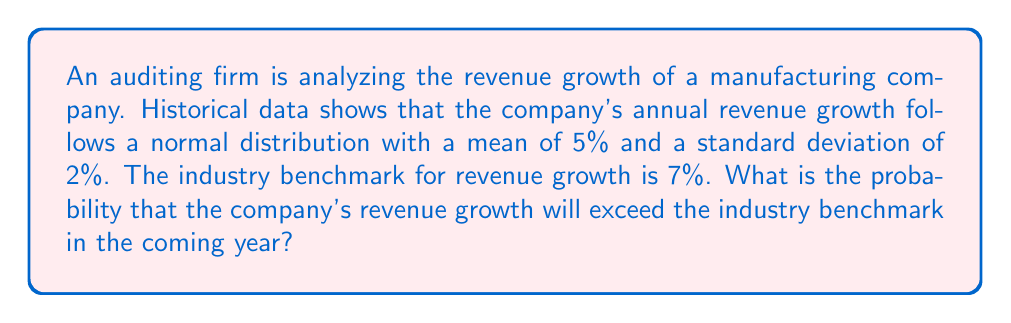Solve this math problem. To solve this problem, we need to follow these steps:

1) We are given that the company's revenue growth follows a normal distribution with:
   Mean ($\mu$) = 5%
   Standard deviation ($\sigma$) = 2%

2) We want to find the probability that the growth exceeds 7% (the industry benchmark).

3) For a normal distribution, we can use the z-score formula:

   $z = \frac{x - \mu}{\sigma}$

   Where x is the value we're interested in (7% in this case).

4) Plugging in the values:

   $z = \frac{7 - 5}{2} = 1$

5) Now we need to find the probability of a z-score greater than 1.

6) Using a standard normal distribution table or calculator, we can find that:

   $P(Z > 1) = 1 - P(Z < 1) = 1 - 0.8413 = 0.1587$

7) Therefore, the probability of the company's revenue growth exceeding the industry benchmark is approximately 0.1587 or 15.87%.
Answer: 0.1587 or 15.87% 